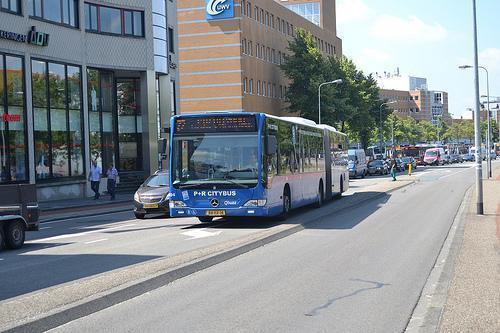How many buses in the picture?
Give a very brief answer. 1. 